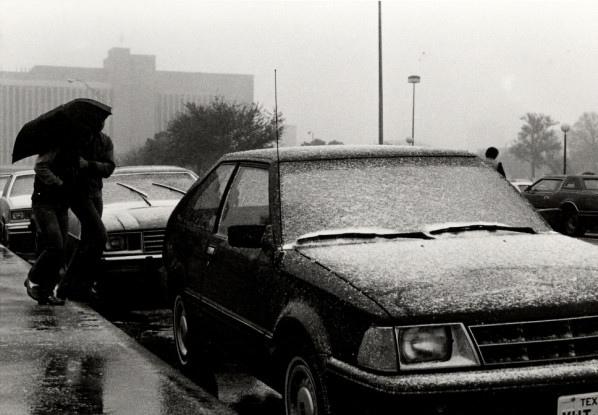Is this a place that snows often?
Be succinct. Yes. What is the man doing?
Answer briefly. Walking. What is all of this sitting on the road?
Give a very brief answer. Snow. Is this metered parking?
Give a very brief answer. No. Is it time for summer camp already?
Be succinct. No. Where is this car going?
Answer briefly. Nowhere. What color is the car?
Short answer required. Black. Does the closest car's windshield need whipping?
Answer briefly. Yes. 